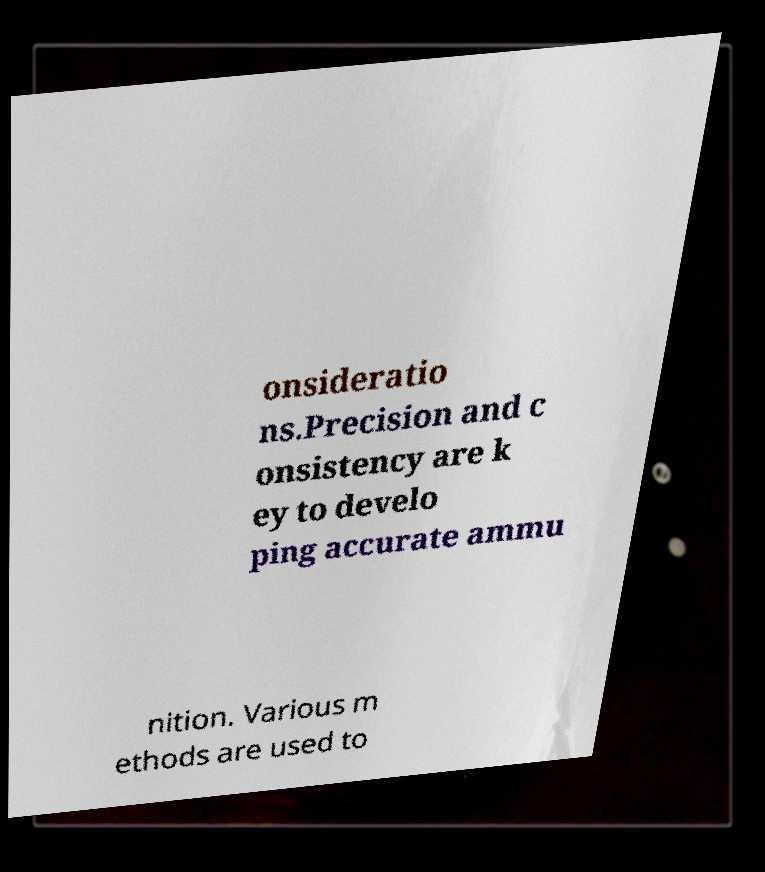Can you accurately transcribe the text from the provided image for me? onsideratio ns.Precision and c onsistency are k ey to develo ping accurate ammu nition. Various m ethods are used to 